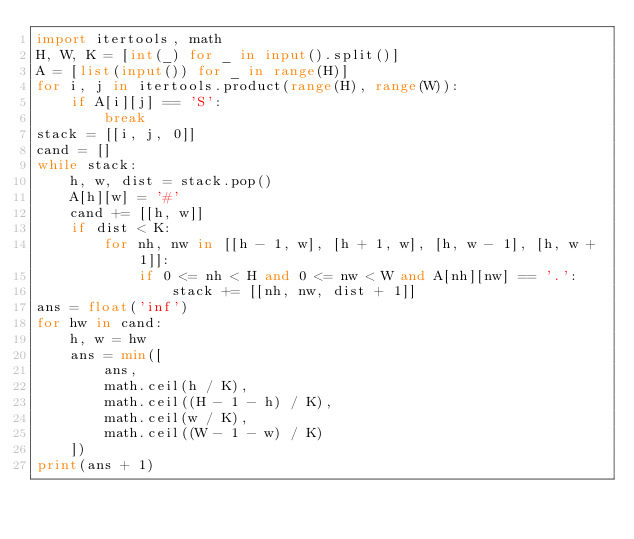<code> <loc_0><loc_0><loc_500><loc_500><_Python_>import itertools, math
H, W, K = [int(_) for _ in input().split()]
A = [list(input()) for _ in range(H)]
for i, j in itertools.product(range(H), range(W)):
    if A[i][j] == 'S':
        break
stack = [[i, j, 0]]
cand = []
while stack:
    h, w, dist = stack.pop()
    A[h][w] = '#'
    cand += [[h, w]]
    if dist < K:
        for nh, nw in [[h - 1, w], [h + 1, w], [h, w - 1], [h, w + 1]]:
            if 0 <= nh < H and 0 <= nw < W and A[nh][nw] == '.':
                stack += [[nh, nw, dist + 1]]
ans = float('inf')
for hw in cand:
    h, w = hw
    ans = min([
        ans,
        math.ceil(h / K),
        math.ceil((H - 1 - h) / K),
        math.ceil(w / K),
        math.ceil((W - 1 - w) / K)
    ])
print(ans + 1)
</code> 